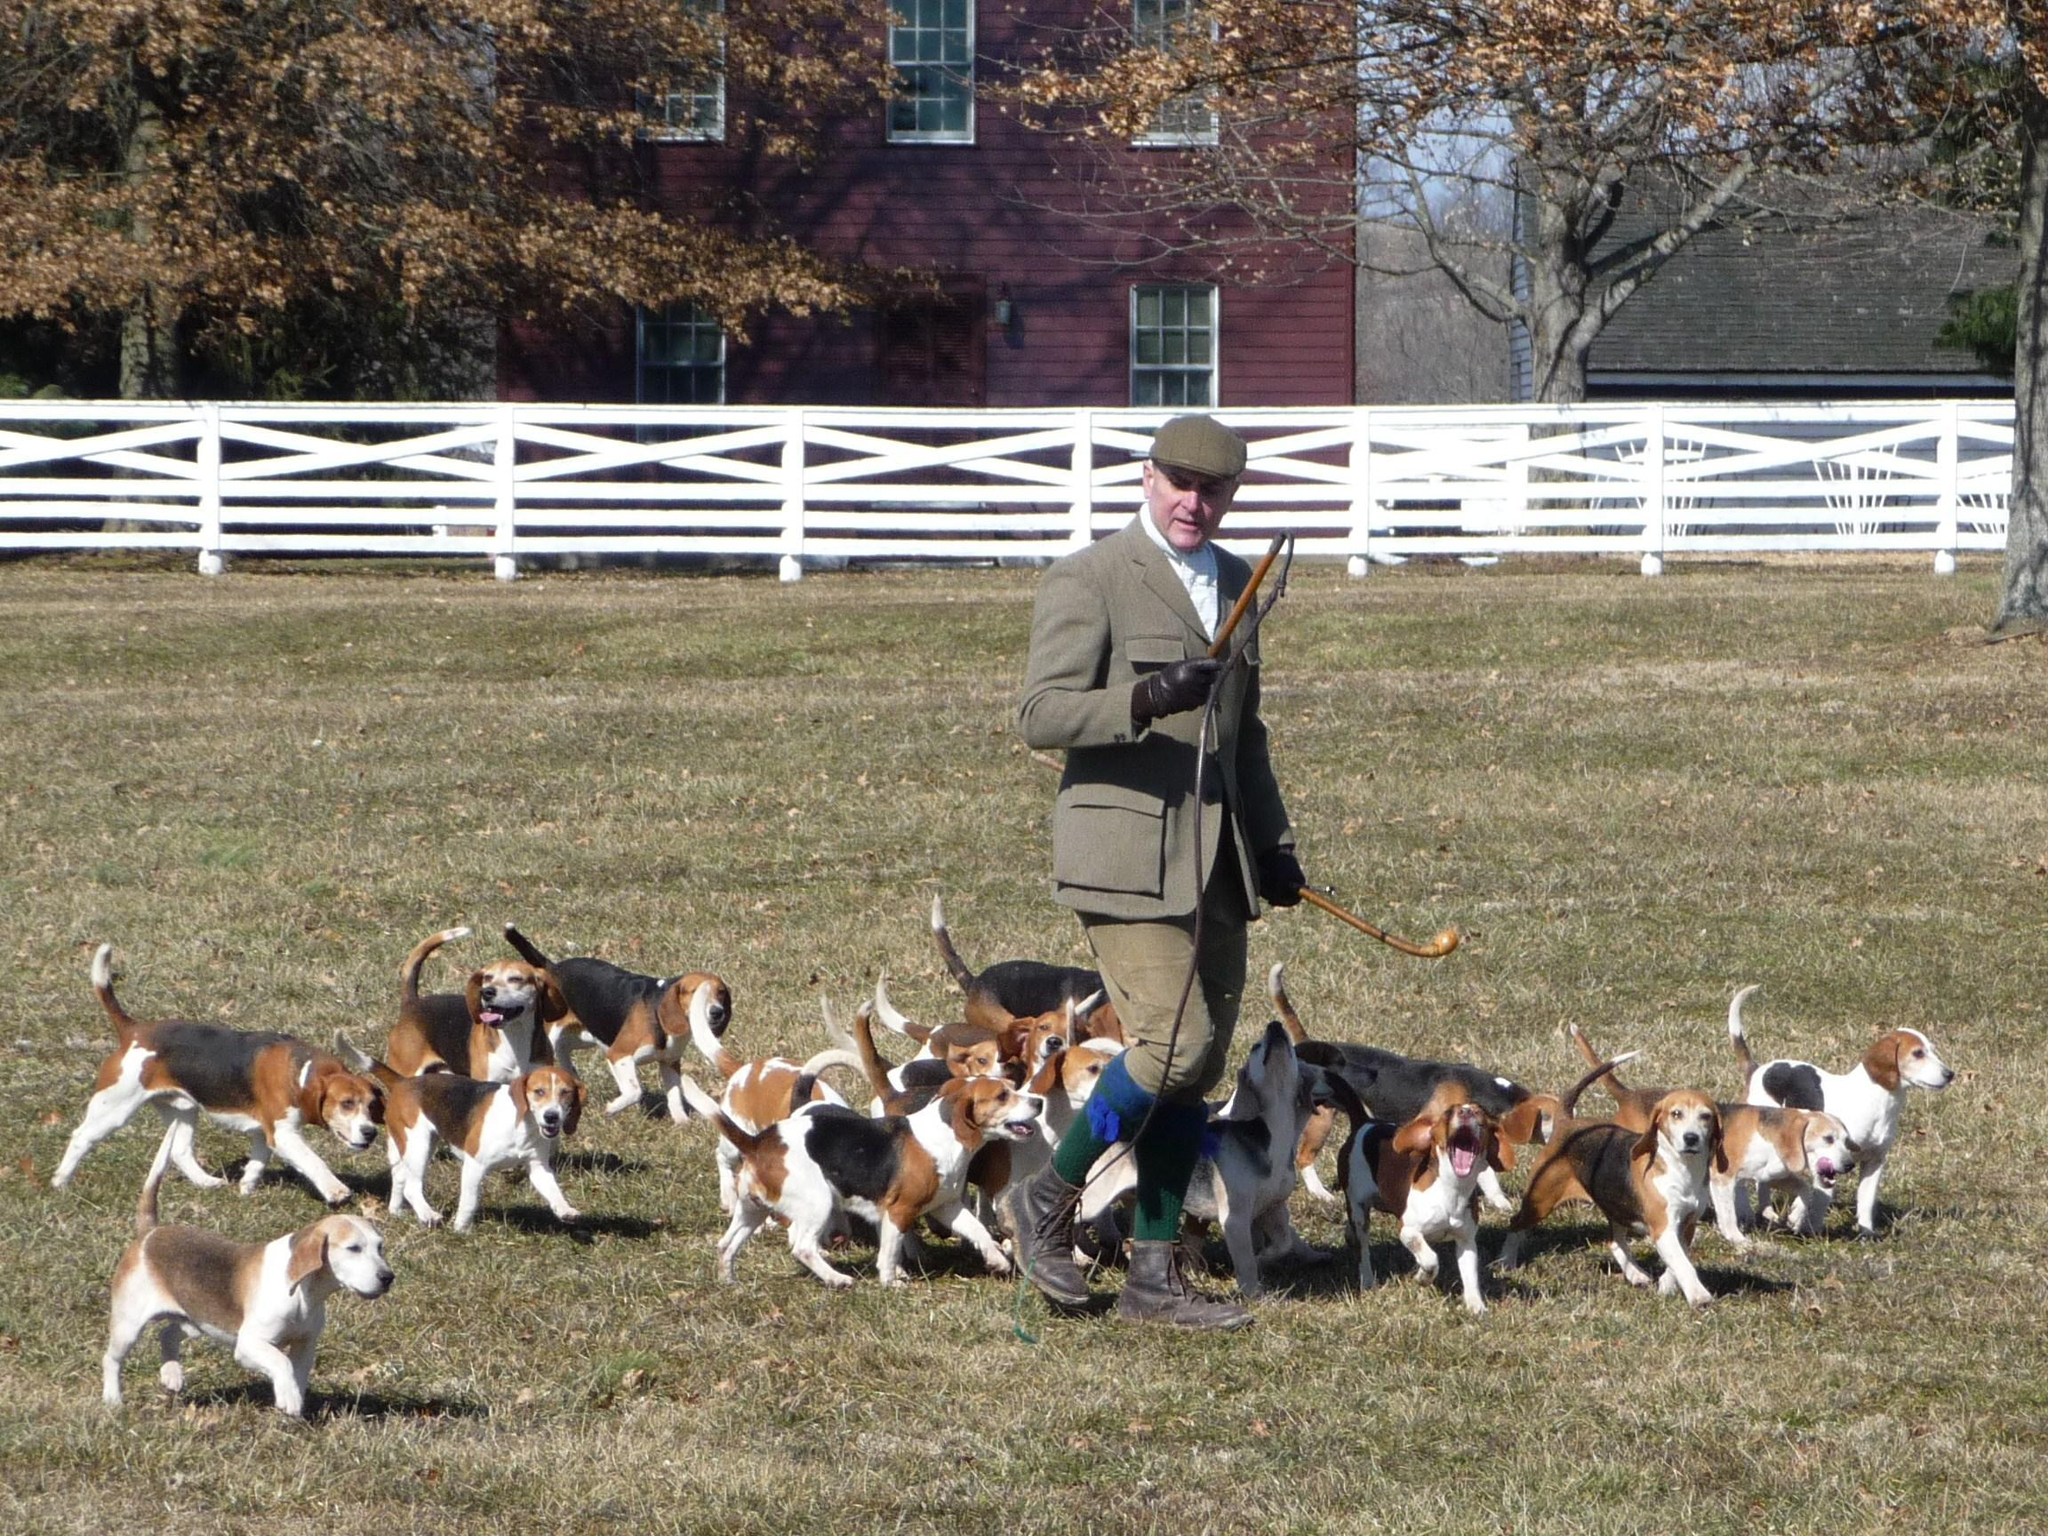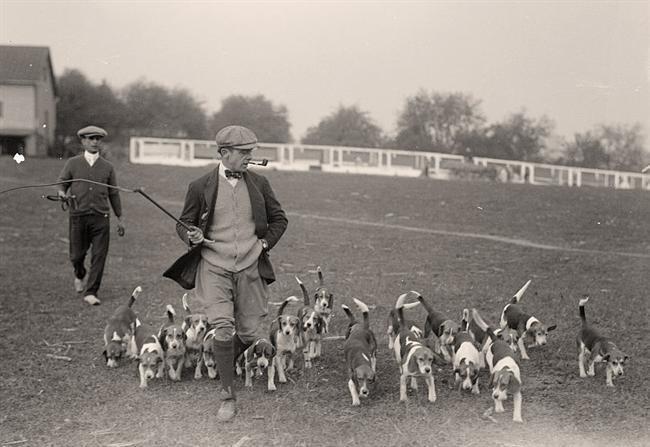The first image is the image on the left, the second image is the image on the right. Analyze the images presented: Is the assertion "No humans are in sight in one of the images of hounds." valid? Answer yes or no. No. The first image is the image on the left, the second image is the image on the right. Considering the images on both sides, is "The picture on the right is in black and white." valid? Answer yes or no. Yes. 